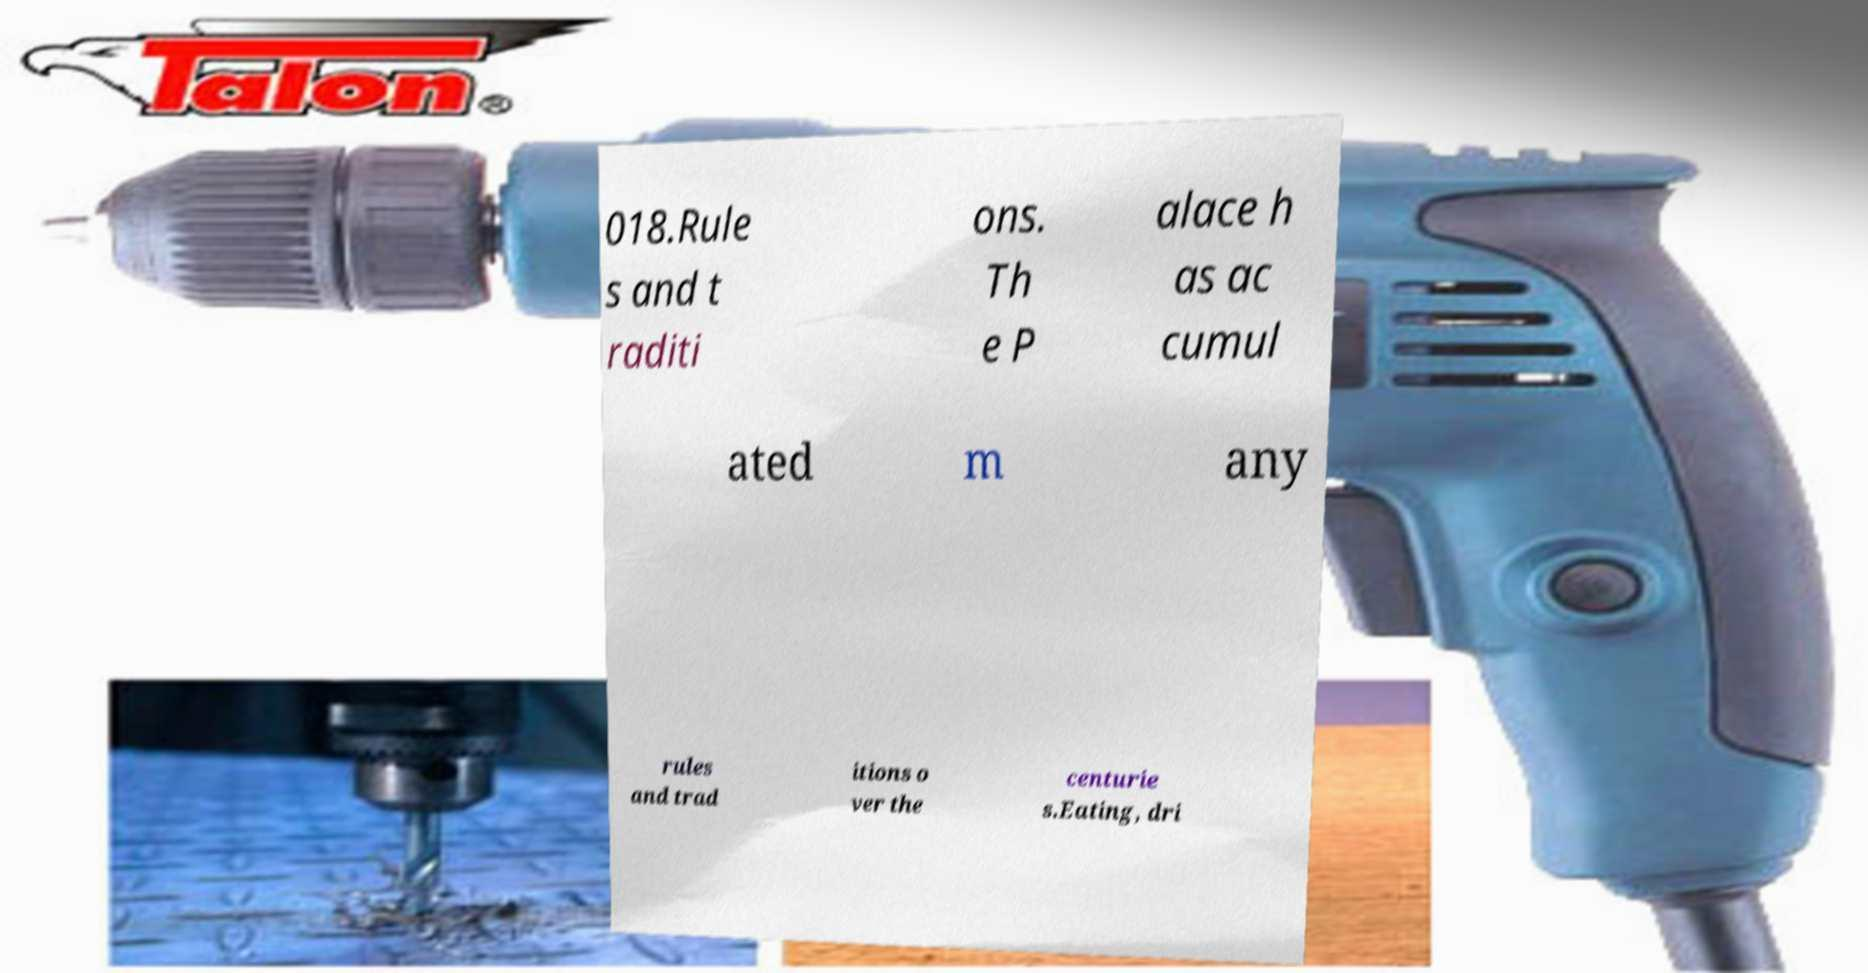Could you assist in decoding the text presented in this image and type it out clearly? 018.Rule s and t raditi ons. Th e P alace h as ac cumul ated m any rules and trad itions o ver the centurie s.Eating, dri 